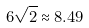<formula> <loc_0><loc_0><loc_500><loc_500>6 \sqrt { 2 } \approx 8 . 4 9</formula> 